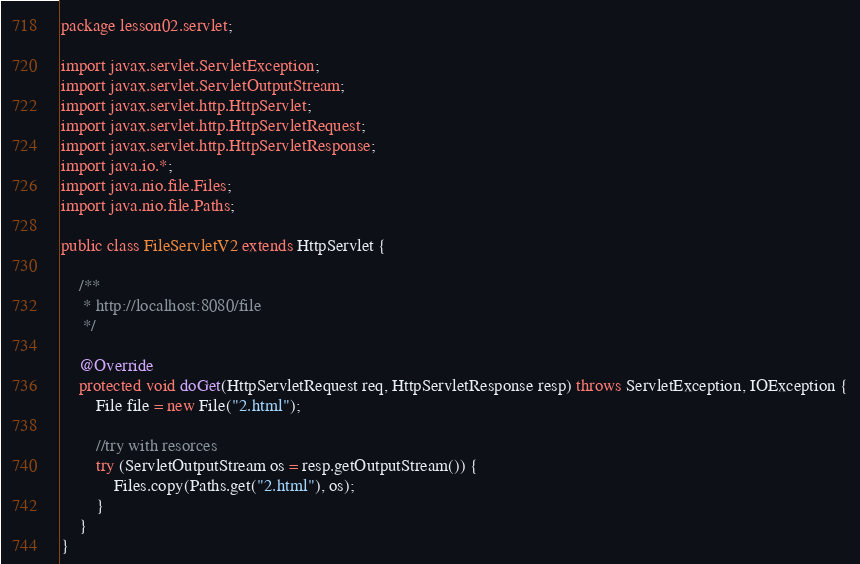<code> <loc_0><loc_0><loc_500><loc_500><_Java_>package lesson02.servlet;

import javax.servlet.ServletException;
import javax.servlet.ServletOutputStream;
import javax.servlet.http.HttpServlet;
import javax.servlet.http.HttpServletRequest;
import javax.servlet.http.HttpServletResponse;
import java.io.*;
import java.nio.file.Files;
import java.nio.file.Paths;

public class FileServletV2 extends HttpServlet {

    /**
     * http://localhost:8080/file
     */

    @Override
    protected void doGet(HttpServletRequest req, HttpServletResponse resp) throws ServletException, IOException {
        File file = new File("2.html");

        //try with resorces
        try (ServletOutputStream os = resp.getOutputStream()) {
            Files.copy(Paths.get("2.html"), os);
        }
    }
}
</code> 